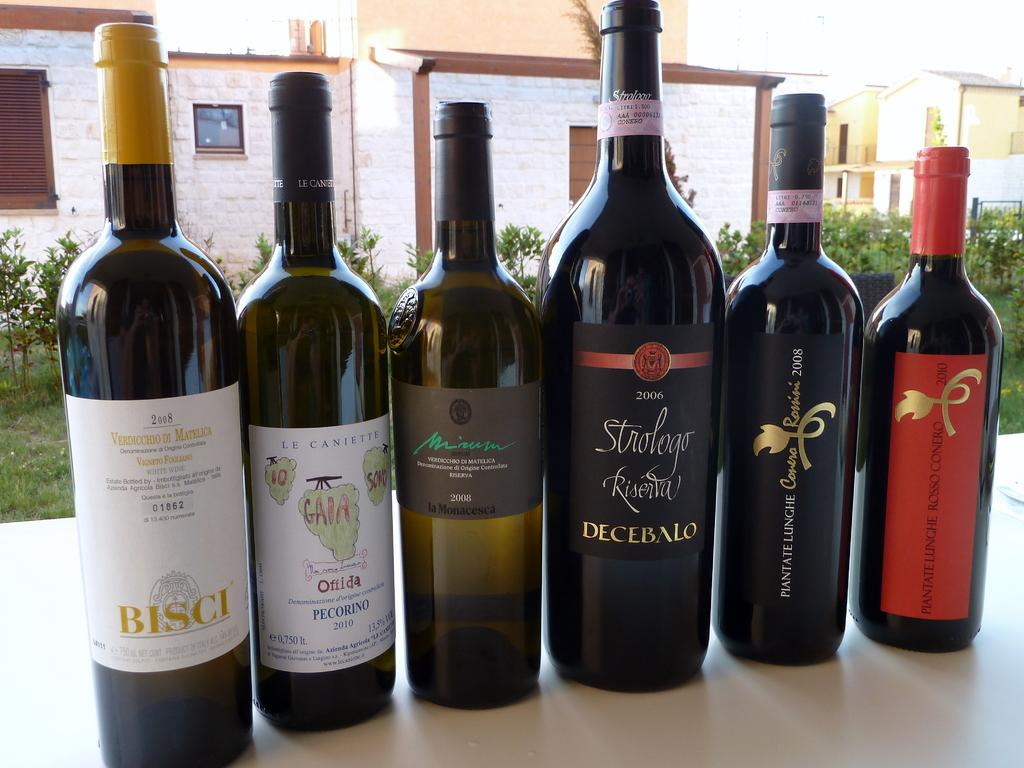<image>
Offer a succinct explanation of the picture presented. A bottle of Verdicchio Di Matelica from Bisci with five other bottles of wine. 